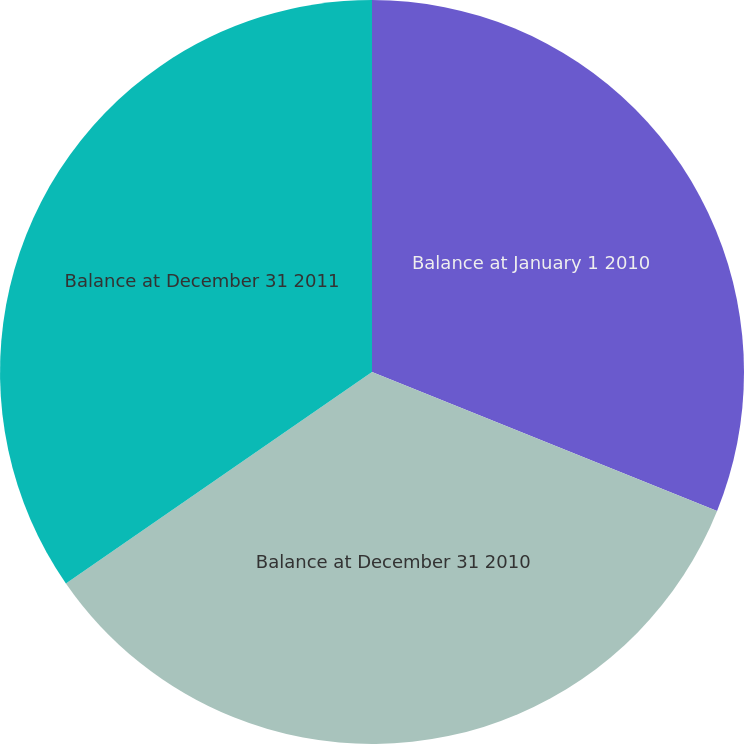Convert chart to OTSL. <chart><loc_0><loc_0><loc_500><loc_500><pie_chart><fcel>Balance at January 1 2010<fcel>Balance at December 31 2010<fcel>Balance at December 31 2011<nl><fcel>31.09%<fcel>34.29%<fcel>34.62%<nl></chart> 